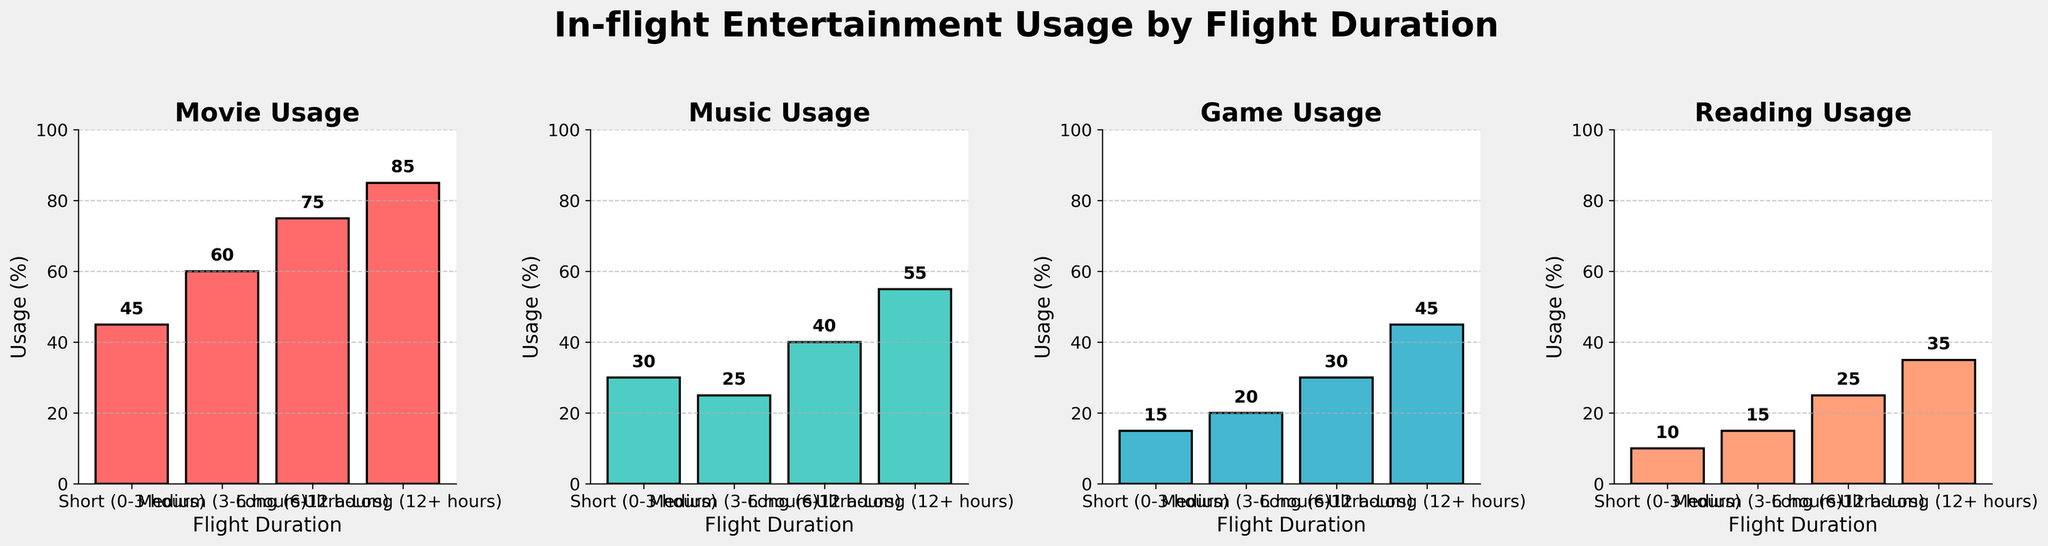What is the movie usage percentage for ultra-long flights? The figure shows the movie usage percentage for each flight duration. For ultra-long flights, the bar representing movie usage reaches 85%.
Answer: 85% Which in-flight entertainment option has the highest usage for medium flights? Among the four categories, the figure shows that movie usage for medium flights has the highest percentage, which is 60%.
Answer: Movie Which flight duration shows the least interest in reading usage? The figure shows the bars for reading usage across different flight durations. The shortest bar for reading usage belongs to short flights, which is 10%.
Answer: Short (0-3 hours) For long flights, by how much does game usage exceed reading usage? For long flights, the figure shows game usage at 30% and reading usage at 25%. Thus, game usage exceeds reading usage by (30% - 25%) = 5%.
Answer: 5% Identify the category where usage increases the most when moving from medium to long flights. By comparing the height of the bars between medium and long flight durations, the highest increase is in music usage, which goes from 25% to 40%, a 15% increase.
Answer: Music Among short, medium, and long flight durations, which category shows the most uniform usage increase? Observing the bars across these flight durations, movie usage increases uniformly from 45% to 60% to 75%, with consistent increments.
Answer: Movie Is music usage for ultra-long flights higher than game usage for long flights? The figure shows music usage for ultra-long flights at 55% and game usage for long flights at 30%, thus confirming that the former is higher.
Answer: Yes What is the total in-flight entertainment usage percentage for all categories combined in short flights? Summing the percentages for all categories in short flights: 45% (Movie) + 30% (Music) + 15% (Game) + 10% (Reading) = 100%.
Answer: 100% When comparing movie and reading usage, which one has a steeper increase from medium to ultra-long flights? Movie usage increases from 60% to 85% (25% increase), while reading usage increases from 15% to 35% (20% increase). Thus, movie usage has a steeper increase.
Answer: Movie 